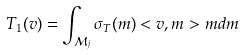Convert formula to latex. <formula><loc_0><loc_0><loc_500><loc_500>T _ { 1 } ( v ) = \int _ { \mathcal { M } _ { j } } \sigma _ { T } ( m ) < v , m > m d m</formula> 